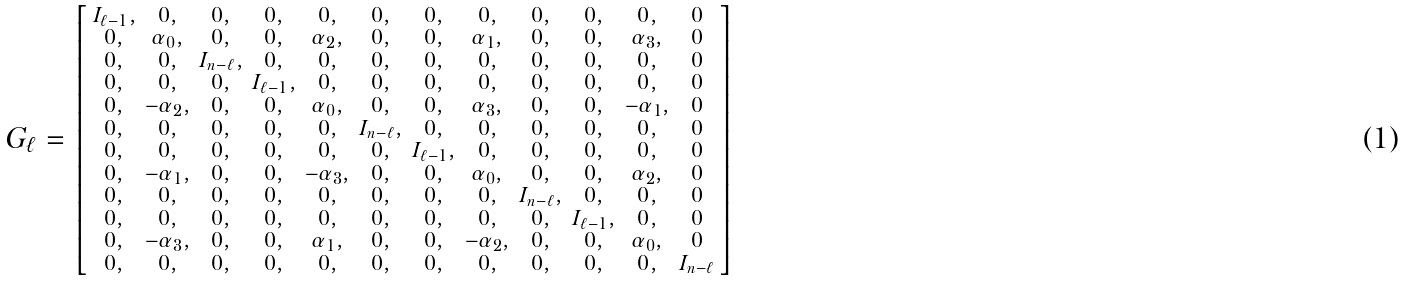<formula> <loc_0><loc_0><loc_500><loc_500>G _ { \ell } = \left [ \begin{smallmatrix} I _ { \ell - 1 } , & 0 , & 0 , & 0 , & 0 , & 0 , & 0 , & 0 , & 0 , & 0 , & 0 , & 0 \\ 0 , & \alpha _ { 0 } , & 0 , & 0 , & \alpha _ { 2 } , & 0 , & 0 , & \alpha _ { 1 } , & 0 , & 0 , & \alpha _ { 3 } , & 0 \\ 0 , & 0 , & I _ { n - \ell } , & 0 , & 0 , & 0 , & 0 , & 0 , & 0 , & 0 , & 0 , & 0 \\ 0 , & 0 , & 0 , & I _ { \ell - 1 } , & 0 , & 0 , & 0 , & 0 , & 0 , & 0 , & 0 , & 0 \\ 0 , & - \alpha _ { 2 } , & 0 , & 0 , & \alpha _ { 0 } , & 0 , & 0 , & \alpha _ { 3 } , & 0 , & 0 , & - \alpha _ { 1 } , & 0 \\ 0 , & 0 , & 0 , & 0 , & 0 , & I _ { n - \ell } , & 0 , & 0 , & 0 , & 0 , & 0 , & 0 \\ 0 , & 0 , & 0 , & 0 , & 0 , & 0 , & I _ { \ell - 1 } , & 0 , & 0 , & 0 , & 0 , & 0 \\ 0 , & - \alpha _ { 1 } , & 0 , & 0 , & - \alpha _ { 3 } , & 0 , & 0 , & \alpha _ { 0 } , & 0 , & 0 , & \alpha _ { 2 } , & 0 \\ 0 , & 0 , & 0 , & 0 , & 0 , & 0 , & 0 , & 0 , & I _ { n - \ell } , & 0 , & 0 , & 0 \\ 0 , & 0 , & 0 , & 0 , & 0 , & 0 , & 0 , & 0 , & 0 , & I _ { \ell - 1 } , & 0 , & 0 \\ 0 , & - \alpha _ { 3 } , & 0 , & 0 , & \alpha _ { 1 } , & 0 , & 0 , & - \alpha _ { 2 } , & 0 , & 0 , & \alpha _ { 0 } , & 0 \\ 0 , & 0 , & 0 , & 0 , & 0 , & 0 , & 0 , & 0 , & 0 , & 0 , & 0 , & I _ { n - \ell } \\ \end{smallmatrix} \right ]</formula> 